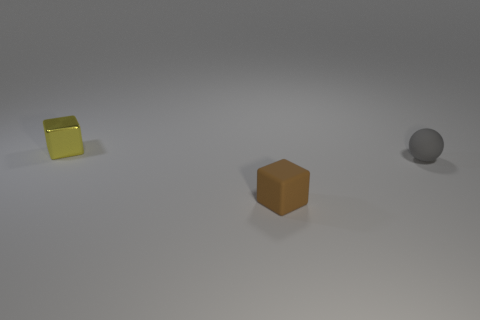Are there any other things that have the same shape as the small gray object?
Make the answer very short. No. Is the number of small gray things that are in front of the small brown thing the same as the number of cyan metallic cylinders?
Your response must be concise. Yes. There is a matte object that is in front of the gray sphere; is it the same shape as the small gray object?
Provide a short and direct response. No. The gray thing is what shape?
Provide a succinct answer. Sphere. What material is the tiny cube that is behind the small rubber object right of the cube on the right side of the tiny yellow block?
Offer a very short reply. Metal. What number of things are either small cubes or large gray blocks?
Offer a very short reply. 2. Is the thing right of the small brown rubber thing made of the same material as the yellow object?
Provide a succinct answer. No. What number of objects are objects that are in front of the yellow metal object or tiny metal things?
Ensure brevity in your answer.  3. There is another small object that is the same material as the gray object; what color is it?
Ensure brevity in your answer.  Brown. Is there a gray rubber thing that has the same size as the rubber sphere?
Your response must be concise. No. 